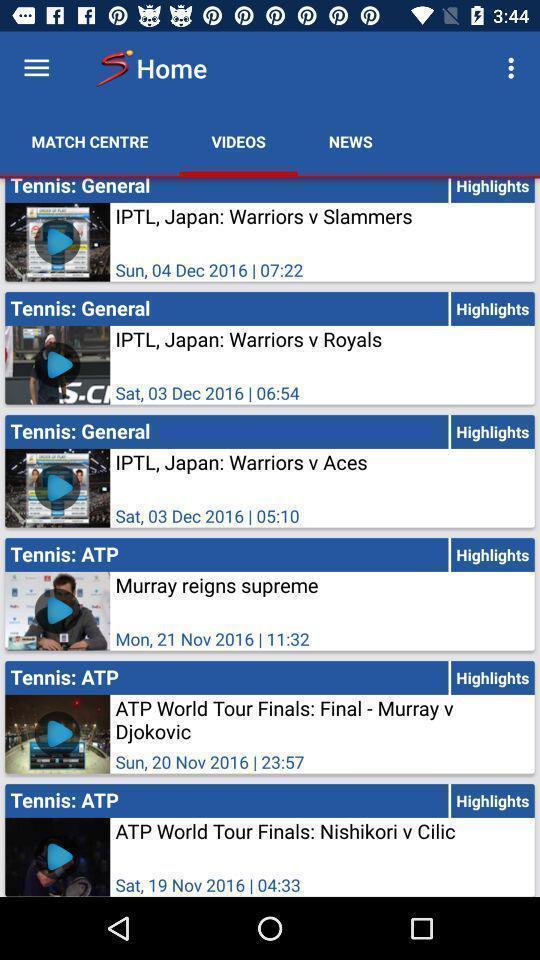Give me a narrative description of this picture. Screen shows multiple options in sports application. 